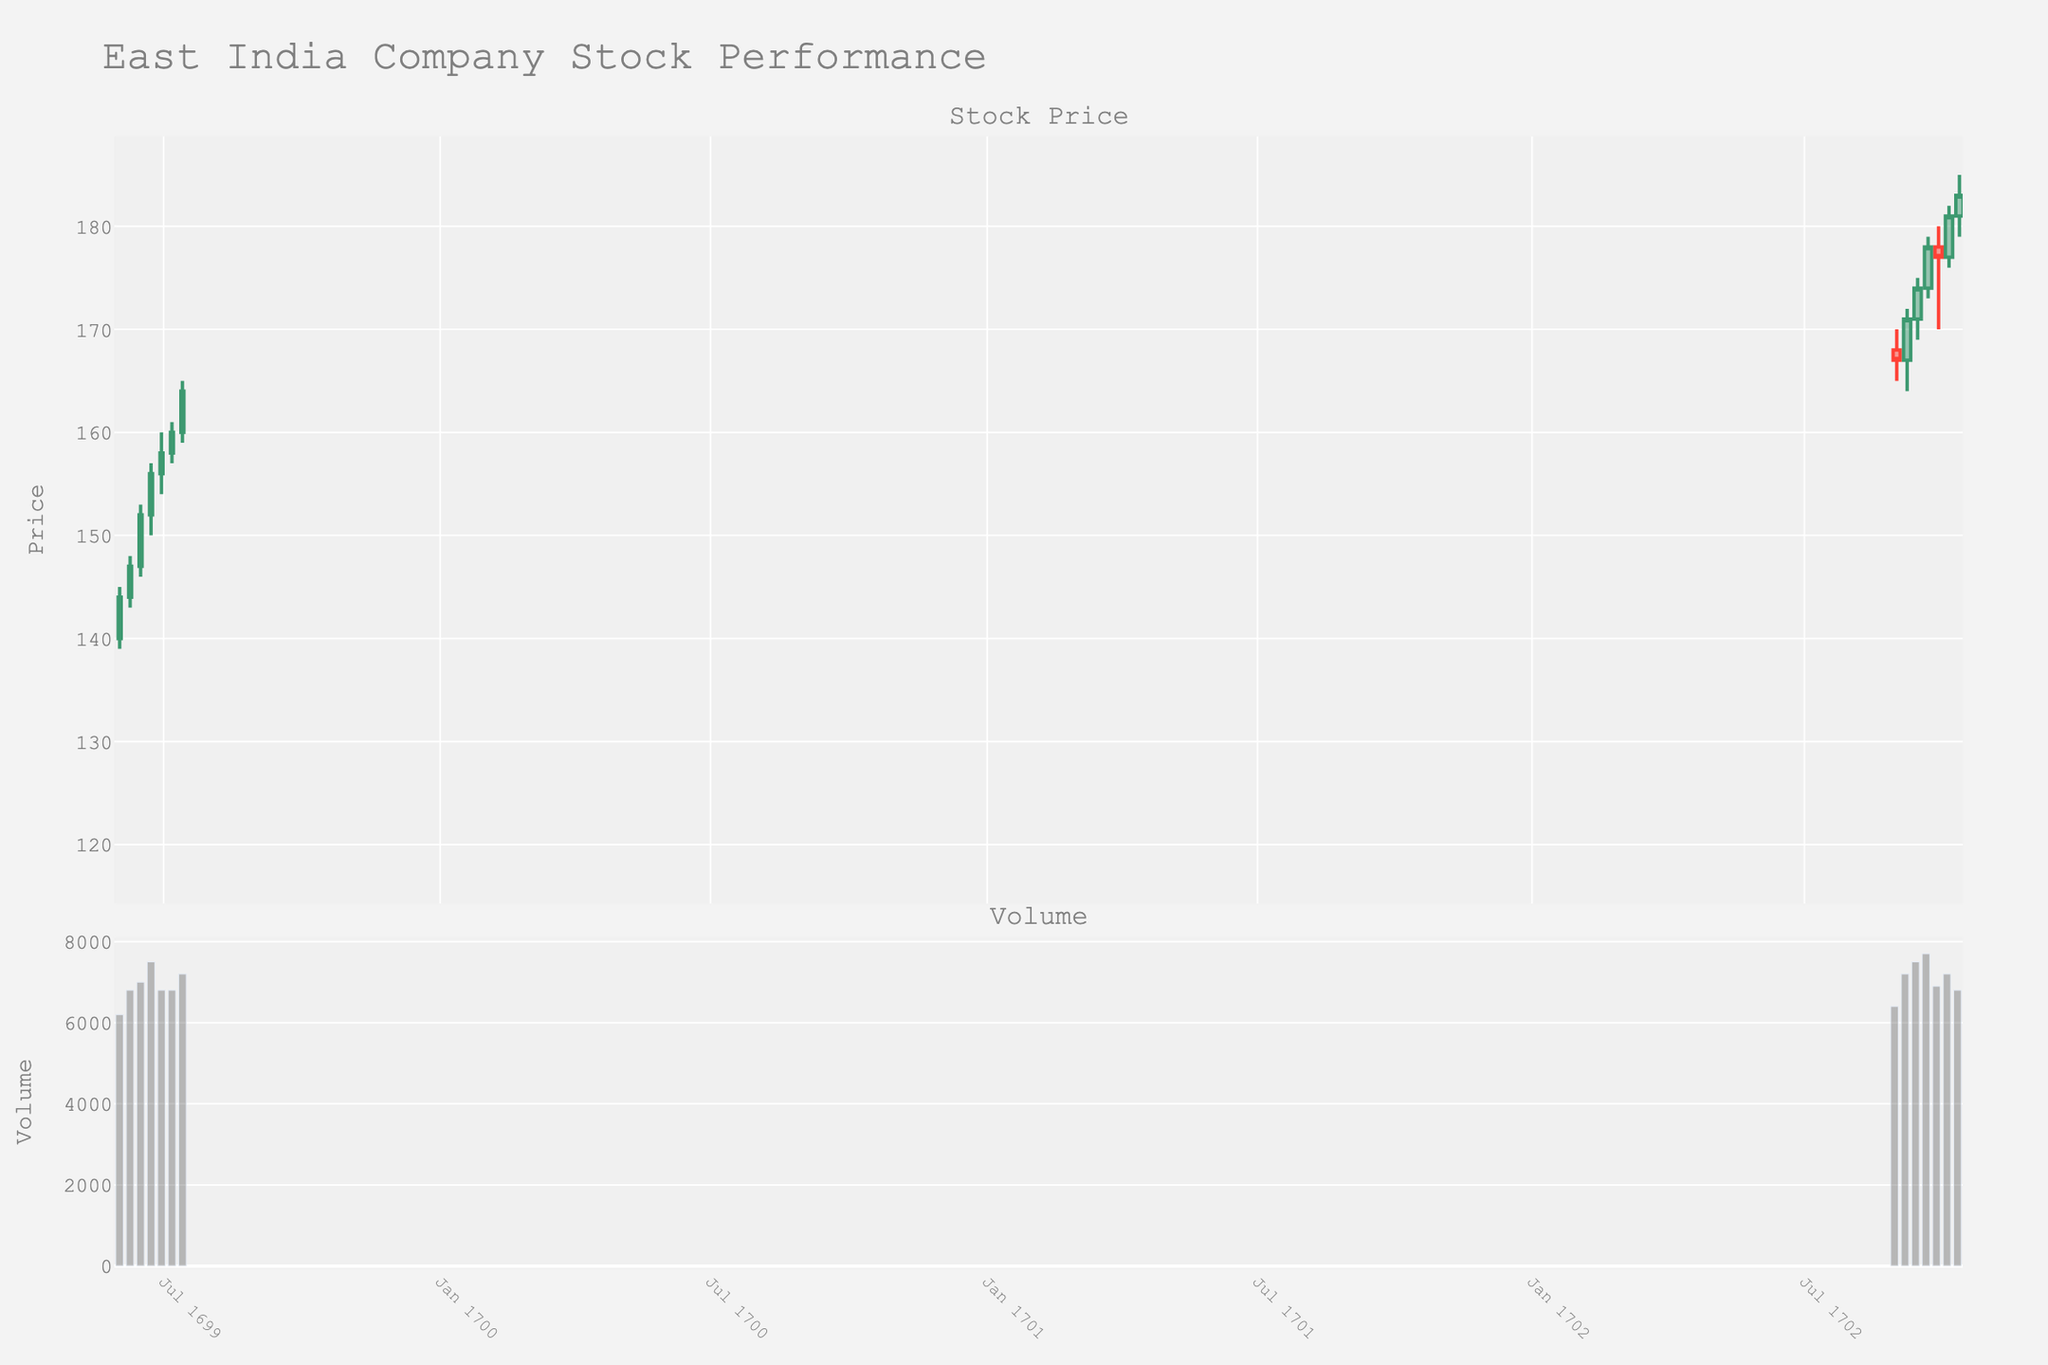what is the title of the candlestick plot? The title of the plot is usually displayed at the top of the figure. By looking at the top area, you can see the title text. In this case, the title is "East India Company Stock Performance".
Answer: East India Company Stock Performance When did the stock price have the highest closing value in the given data? To find this, look at the upper part of each candlestick (the closing price) and find which one goes up the highest. Checking all candlesticks, you will see the highest closing value is on 1702-09-29, where the price closes at 178.
Answer: 1702-09-29 how many data points are displayed on the plot? Count the number of candlesticks on the plot. Each candlestick represents a single data point. By counting all candlesticks, we can see there are 21 data points in the plot.
Answer: 21 what was the volume of stocks traded on 1702-09-01? By looking at the bar corresponding to this date in the volume subplot, we can see the height of the bar which represents the volume. The volume traded on this date is 6400.
Answer: 6400 Which week had the largest increase in stock price? To determine the largest increase, subtract the opening price from the closing price for each week, and find the week with the highest positive difference. The week with the largest increase is 1702-09-15, where the closing price (174) minus the opening price (171) equals 3.
Answer: 1702-09-15 What is the highest trading volume in the entire dataset? By examining the height of all bars in the volume subplot, we identify the tallest bar. This occurs on 1702-09-22 with a volume of 7700.
Answer: 7700 During which expedition period in 1699 were the opening prices consistently higher each week? By observing the 1699 section, note that the opening prices increase each week from 140 on 1699-06-01 to 160 on 1699-07-13 consecutively.
Answer: June and July 1699 Compare the stock prices between 1696 and 1702. Which year witnessed greater volatility in a single week? Volatility is the difference between the high and low prices in a single week. Calculate the high-low differences for each week in both years and compare the largest differences. 1702 shows greater volatility with a maximum difference of (179 - 170) = 9 during the week of 1702-09-29.
Answer: 1702 What's the trend of stock prices in February 1696? Check the dates in February 1696 and observe the closing prices: 137 (Feb 5), 134 (Feb 12), and 136 (Feb 19). The trend appears volatile but slightly declining.
Answer: Slightly declining 